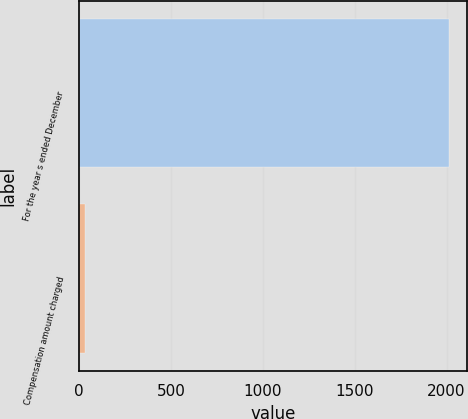Convert chart. <chart><loc_0><loc_0><loc_500><loc_500><bar_chart><fcel>For the year s ended December<fcel>Compensation amount charged<nl><fcel>2013<fcel>32.6<nl></chart> 